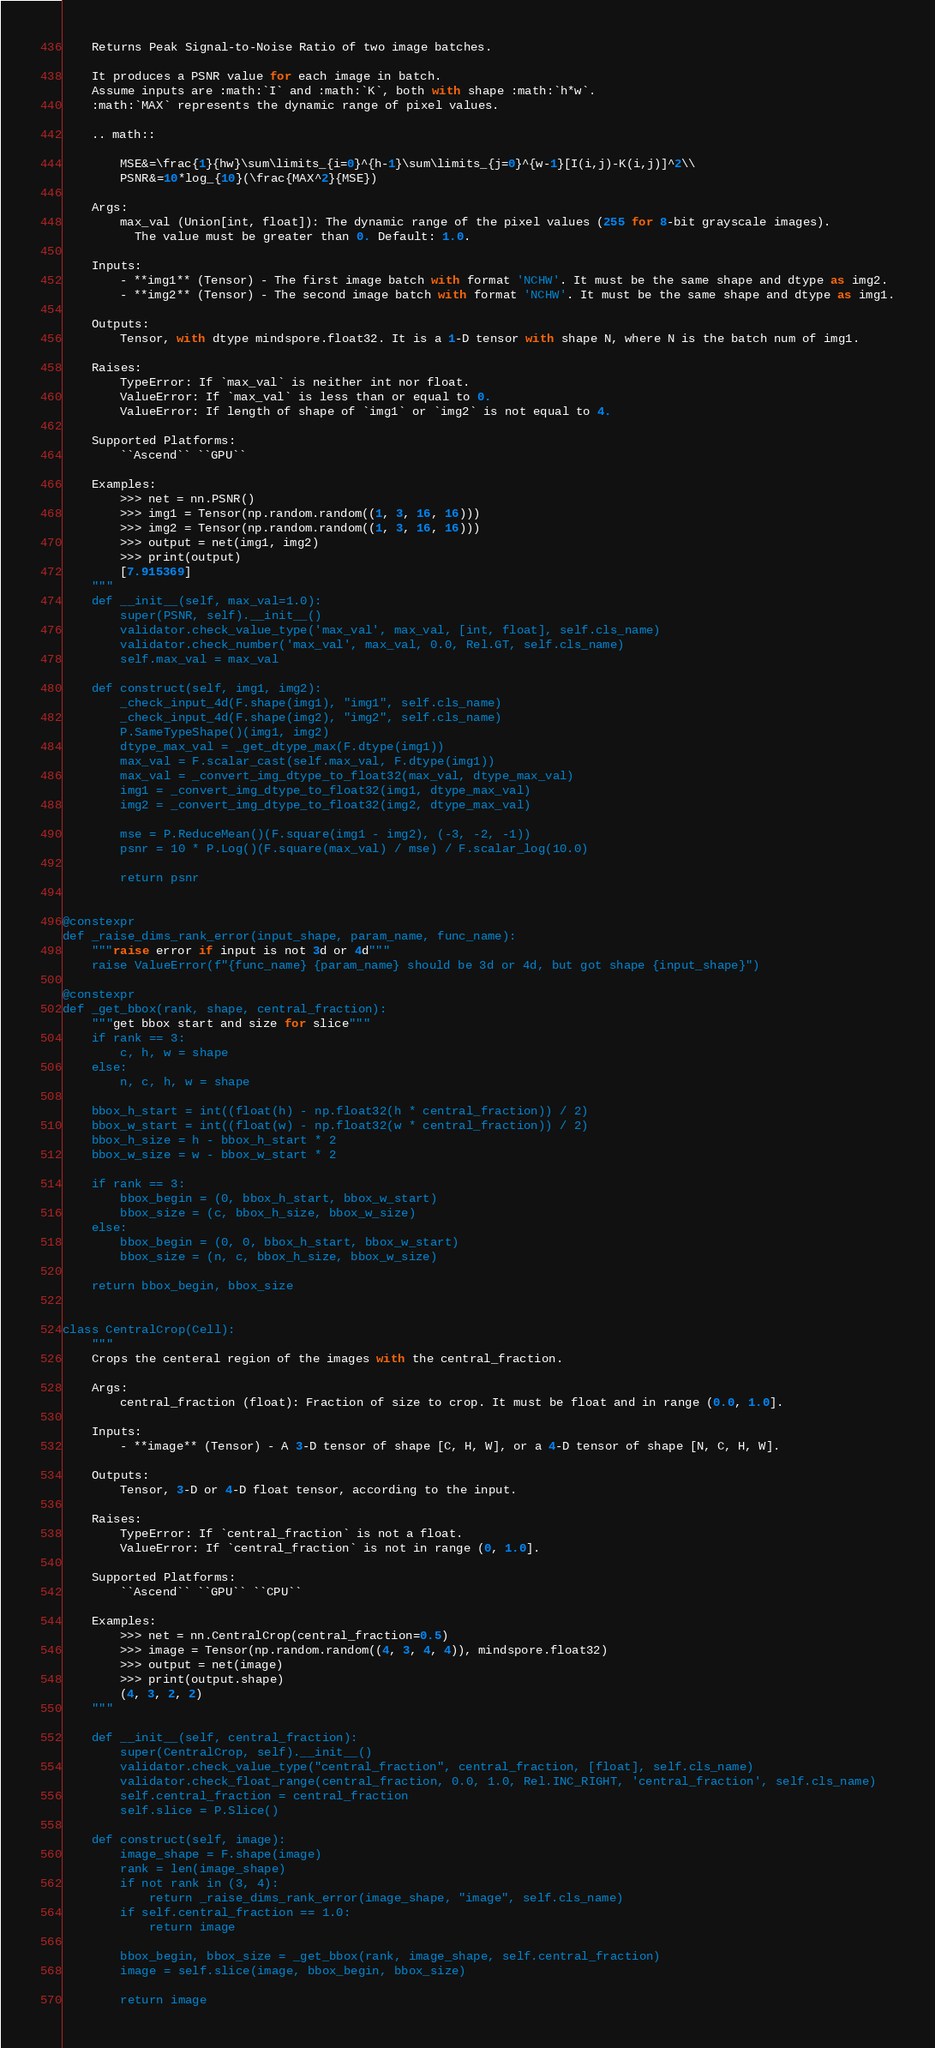Convert code to text. <code><loc_0><loc_0><loc_500><loc_500><_Python_>    Returns Peak Signal-to-Noise Ratio of two image batches.

    It produces a PSNR value for each image in batch.
    Assume inputs are :math:`I` and :math:`K`, both with shape :math:`h*w`.
    :math:`MAX` represents the dynamic range of pixel values.

    .. math::

        MSE&=\frac{1}{hw}\sum\limits_{i=0}^{h-1}\sum\limits_{j=0}^{w-1}[I(i,j)-K(i,j)]^2\\
        PSNR&=10*log_{10}(\frac{MAX^2}{MSE})

    Args:
        max_val (Union[int, float]): The dynamic range of the pixel values (255 for 8-bit grayscale images).
          The value must be greater than 0. Default: 1.0.

    Inputs:
        - **img1** (Tensor) - The first image batch with format 'NCHW'. It must be the same shape and dtype as img2.
        - **img2** (Tensor) - The second image batch with format 'NCHW'. It must be the same shape and dtype as img1.

    Outputs:
        Tensor, with dtype mindspore.float32. It is a 1-D tensor with shape N, where N is the batch num of img1.

    Raises:
        TypeError: If `max_val` is neither int nor float.
        ValueError: If `max_val` is less than or equal to 0.
        ValueError: If length of shape of `img1` or `img2` is not equal to 4.

    Supported Platforms:
        ``Ascend`` ``GPU``

    Examples:
        >>> net = nn.PSNR()
        >>> img1 = Tensor(np.random.random((1, 3, 16, 16)))
        >>> img2 = Tensor(np.random.random((1, 3, 16, 16)))
        >>> output = net(img1, img2)
        >>> print(output)
        [7.915369]
    """
    def __init__(self, max_val=1.0):
        super(PSNR, self).__init__()
        validator.check_value_type('max_val', max_val, [int, float], self.cls_name)
        validator.check_number('max_val', max_val, 0.0, Rel.GT, self.cls_name)
        self.max_val = max_val

    def construct(self, img1, img2):
        _check_input_4d(F.shape(img1), "img1", self.cls_name)
        _check_input_4d(F.shape(img2), "img2", self.cls_name)
        P.SameTypeShape()(img1, img2)
        dtype_max_val = _get_dtype_max(F.dtype(img1))
        max_val = F.scalar_cast(self.max_val, F.dtype(img1))
        max_val = _convert_img_dtype_to_float32(max_val, dtype_max_val)
        img1 = _convert_img_dtype_to_float32(img1, dtype_max_val)
        img2 = _convert_img_dtype_to_float32(img2, dtype_max_val)

        mse = P.ReduceMean()(F.square(img1 - img2), (-3, -2, -1))
        psnr = 10 * P.Log()(F.square(max_val) / mse) / F.scalar_log(10.0)

        return psnr


@constexpr
def _raise_dims_rank_error(input_shape, param_name, func_name):
    """raise error if input is not 3d or 4d"""
    raise ValueError(f"{func_name} {param_name} should be 3d or 4d, but got shape {input_shape}")

@constexpr
def _get_bbox(rank, shape, central_fraction):
    """get bbox start and size for slice"""
    if rank == 3:
        c, h, w = shape
    else:
        n, c, h, w = shape

    bbox_h_start = int((float(h) - np.float32(h * central_fraction)) / 2)
    bbox_w_start = int((float(w) - np.float32(w * central_fraction)) / 2)
    bbox_h_size = h - bbox_h_start * 2
    bbox_w_size = w - bbox_w_start * 2

    if rank == 3:
        bbox_begin = (0, bbox_h_start, bbox_w_start)
        bbox_size = (c, bbox_h_size, bbox_w_size)
    else:
        bbox_begin = (0, 0, bbox_h_start, bbox_w_start)
        bbox_size = (n, c, bbox_h_size, bbox_w_size)

    return bbox_begin, bbox_size


class CentralCrop(Cell):
    """
    Crops the centeral region of the images with the central_fraction.

    Args:
        central_fraction (float): Fraction of size to crop. It must be float and in range (0.0, 1.0].

    Inputs:
        - **image** (Tensor) - A 3-D tensor of shape [C, H, W], or a 4-D tensor of shape [N, C, H, W].

    Outputs:
        Tensor, 3-D or 4-D float tensor, according to the input.

    Raises:
        TypeError: If `central_fraction` is not a float.
        ValueError: If `central_fraction` is not in range (0, 1.0].

    Supported Platforms:
        ``Ascend`` ``GPU`` ``CPU``

    Examples:
        >>> net = nn.CentralCrop(central_fraction=0.5)
        >>> image = Tensor(np.random.random((4, 3, 4, 4)), mindspore.float32)
        >>> output = net(image)
        >>> print(output.shape)
        (4, 3, 2, 2)
    """

    def __init__(self, central_fraction):
        super(CentralCrop, self).__init__()
        validator.check_value_type("central_fraction", central_fraction, [float], self.cls_name)
        validator.check_float_range(central_fraction, 0.0, 1.0, Rel.INC_RIGHT, 'central_fraction', self.cls_name)
        self.central_fraction = central_fraction
        self.slice = P.Slice()

    def construct(self, image):
        image_shape = F.shape(image)
        rank = len(image_shape)
        if not rank in (3, 4):
            return _raise_dims_rank_error(image_shape, "image", self.cls_name)
        if self.central_fraction == 1.0:
            return image

        bbox_begin, bbox_size = _get_bbox(rank, image_shape, self.central_fraction)
        image = self.slice(image, bbox_begin, bbox_size)

        return image
</code> 